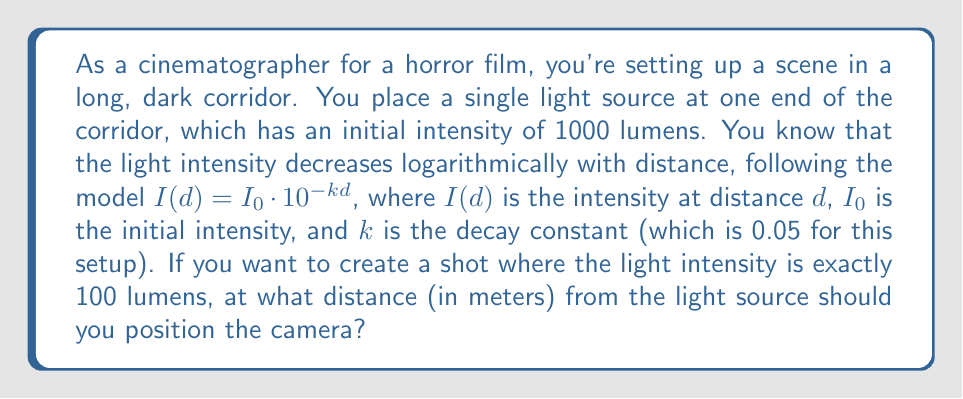Give your solution to this math problem. To solve this problem, we need to use the logarithmic model for light intensity decay:

$$I(d) = I_0 \cdot 10^{-kd}$$

We're given:
$I_0 = 1000$ lumens (initial intensity)
$k = 0.05$ (decay constant)
$I(d) = 100$ lumens (desired intensity)

We need to solve for $d$ (distance).

1) Substitute the known values into the equation:
   $$100 = 1000 \cdot 10^{-0.05d}$$

2) Divide both sides by 1000:
   $$0.1 = 10^{-0.05d}$$

3) Take the logarithm (base 10) of both sides:
   $$\log_{10}(0.1) = \log_{10}(10^{-0.05d})$$

4) Simplify the right side using the logarithm property $\log_a(a^x) = x$:
   $$\log_{10}(0.1) = -0.05d$$

5) Solve for $d$:
   $$d = -\frac{\log_{10}(0.1)}{0.05}$$

6) Calculate the result:
   $$d = -\frac{-1}{0.05} = 20$$

Therefore, the camera should be positioned 20 meters from the light source.
Answer: 20 meters 